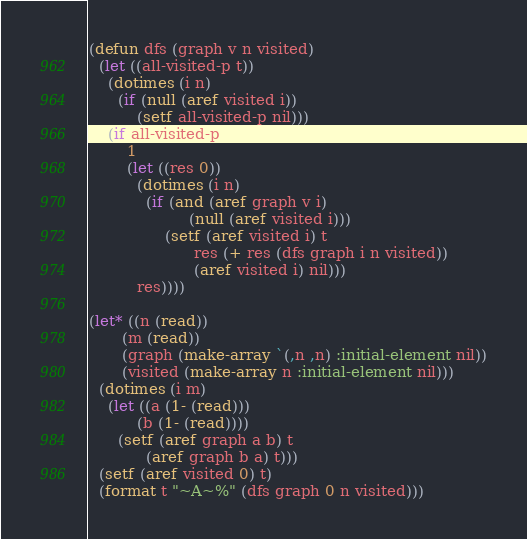Convert code to text. <code><loc_0><loc_0><loc_500><loc_500><_Lisp_>(defun dfs (graph v n visited)
  (let ((all-visited-p t))
    (dotimes (i n)
      (if (null (aref visited i))
          (setf all-visited-p nil)))
    (if all-visited-p
        1
        (let ((res 0))
          (dotimes (i n)
            (if (and (aref graph v i)
                     (null (aref visited i)))
                (setf (aref visited i) t
                      res (+ res (dfs graph i n visited))
                      (aref visited i) nil)))
          res))))

(let* ((n (read))
       (m (read))
       (graph (make-array `(,n ,n) :initial-element nil))
       (visited (make-array n :initial-element nil)))
  (dotimes (i m)
    (let ((a (1- (read)))
          (b (1- (read))))
      (setf (aref graph a b) t
            (aref graph b a) t)))
  (setf (aref visited 0) t)
  (format t "~A~%" (dfs graph 0 n visited)))</code> 